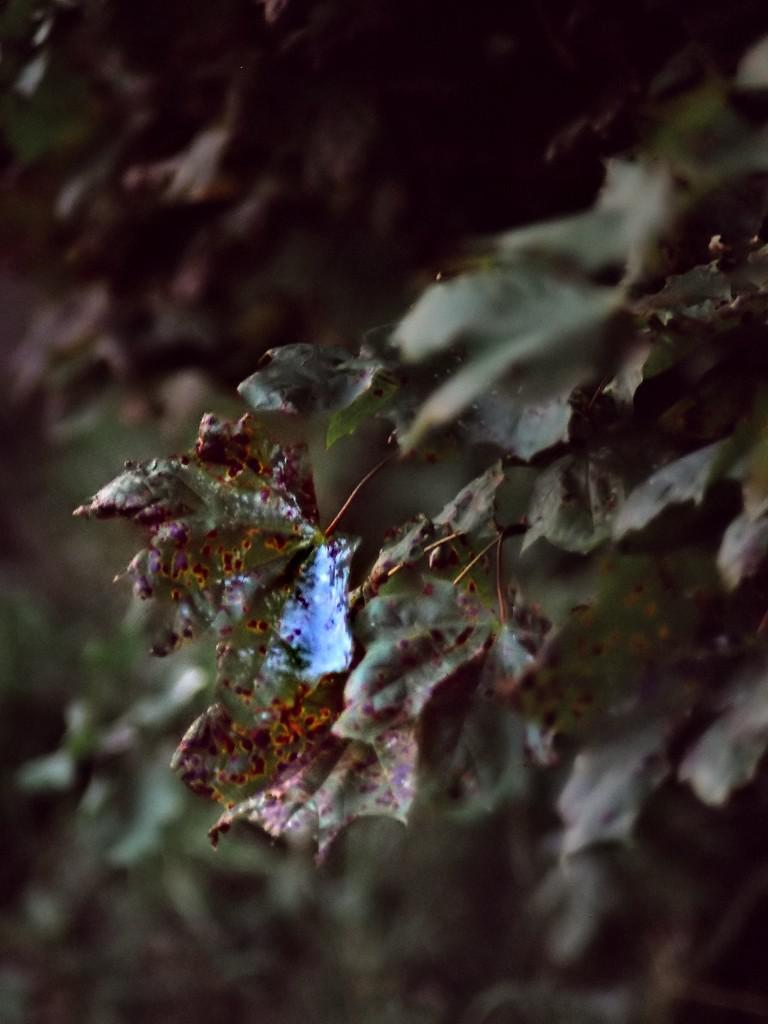What type of insects can be seen on the leaves of a tree in the image? There are ants on the leaves of a tree in the image. What can be seen in the background of the image? There are trees in the background of the image. What type of tin can be seen hanging from the branches of the trees in the image? There is no tin present in the image; it features ants on the leaves of a tree and trees in the background. 